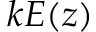<formula> <loc_0><loc_0><loc_500><loc_500>k E ( z )</formula> 